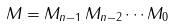Convert formula to latex. <formula><loc_0><loc_0><loc_500><loc_500>M = M _ { n - 1 } \, M _ { n - 2 } \cdots M _ { 0 }</formula> 